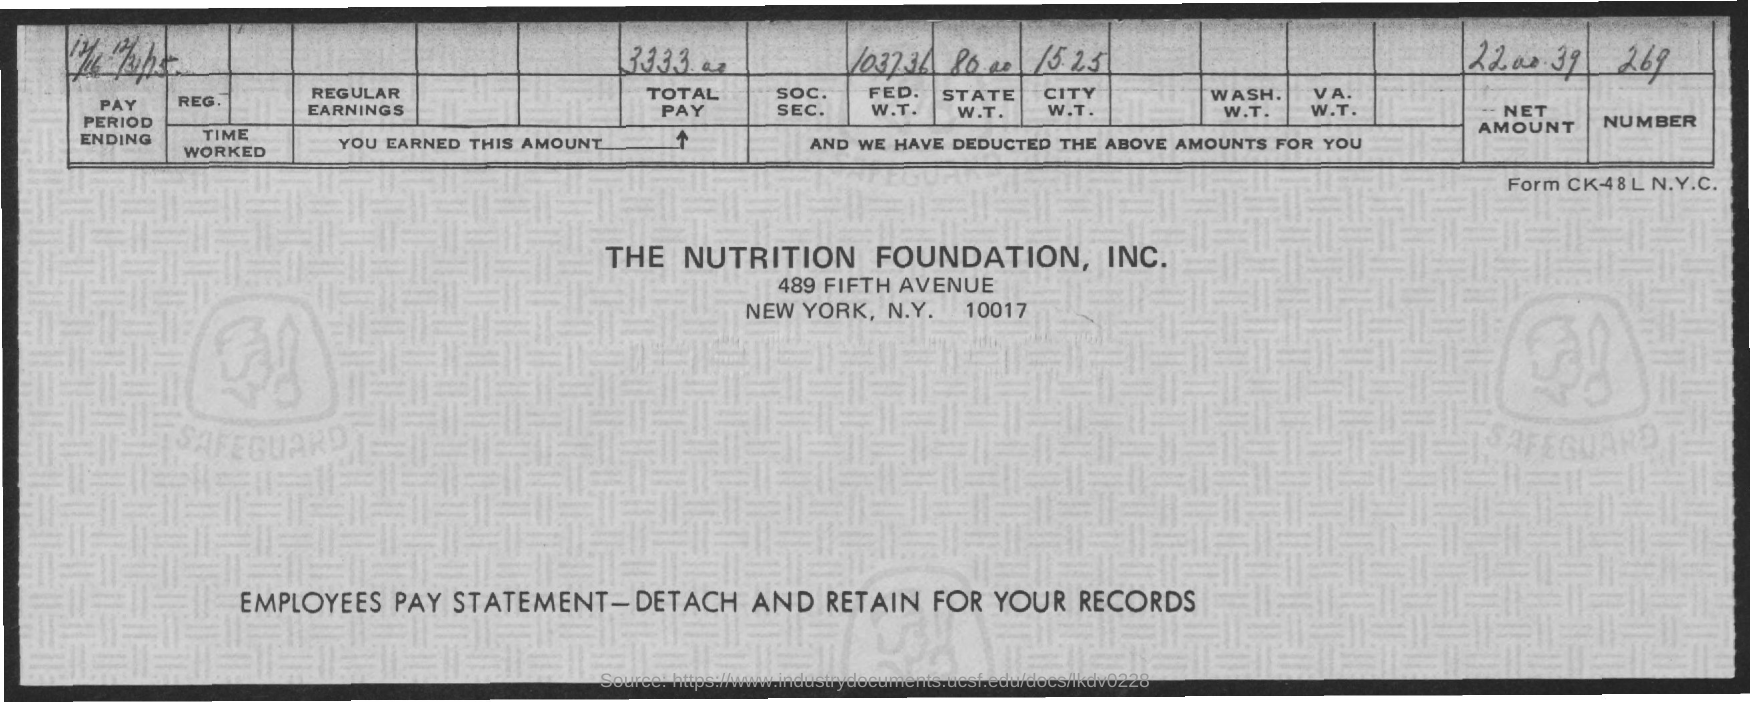Highlight a few significant elements in this photo. I declare that "THE NUTRITION FOUNDATION, INC." is located in NEW YORK. Please mention the "CITY W.T." amount deducted of 15.25... Please mention the number provided, which is 269. The name of the foundation provided is THE NUTRITION FOUNDATION, INC. The amount of "TOTAL PAY" is 3333.00. 